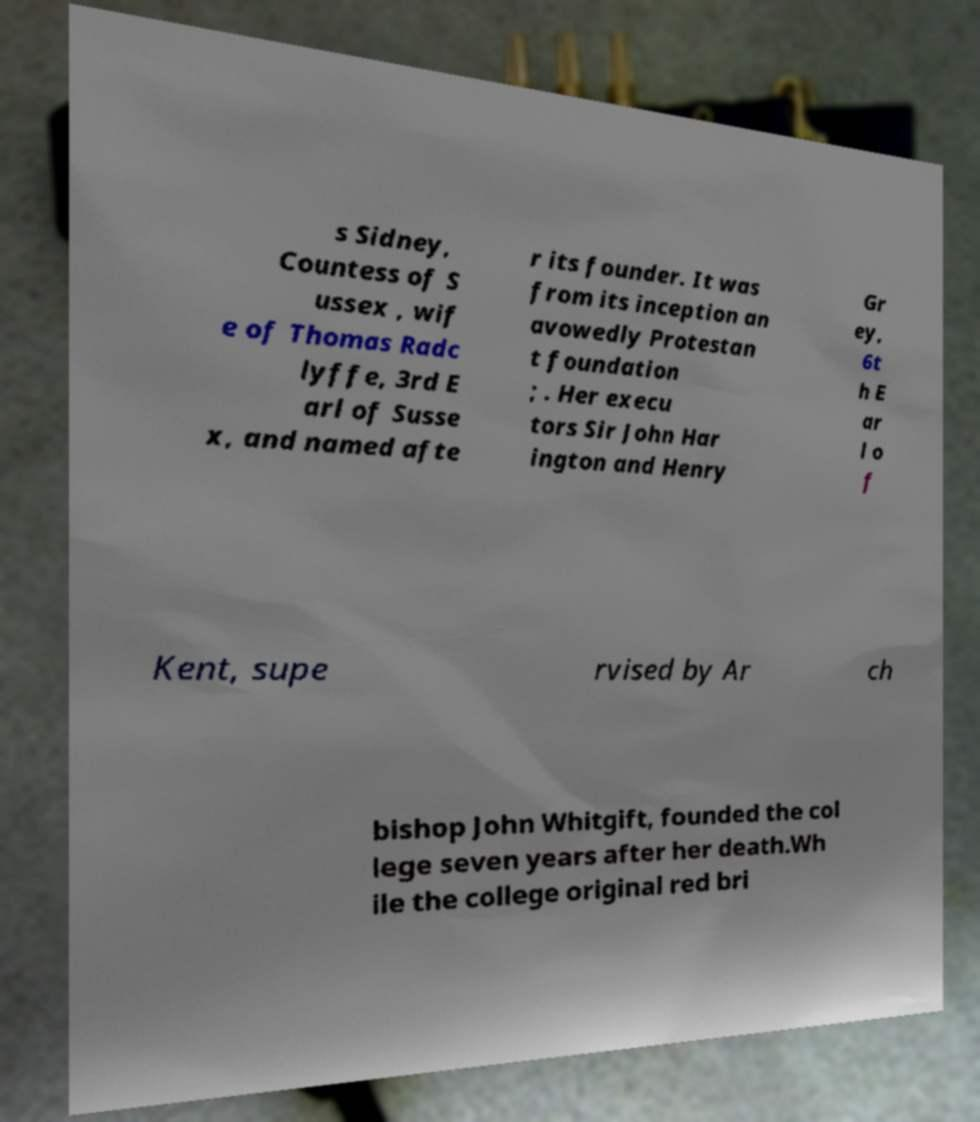I need the written content from this picture converted into text. Can you do that? s Sidney, Countess of S ussex , wif e of Thomas Radc lyffe, 3rd E arl of Susse x, and named afte r its founder. It was from its inception an avowedly Protestan t foundation ; . Her execu tors Sir John Har ington and Henry Gr ey, 6t h E ar l o f Kent, supe rvised by Ar ch bishop John Whitgift, founded the col lege seven years after her death.Wh ile the college original red bri 